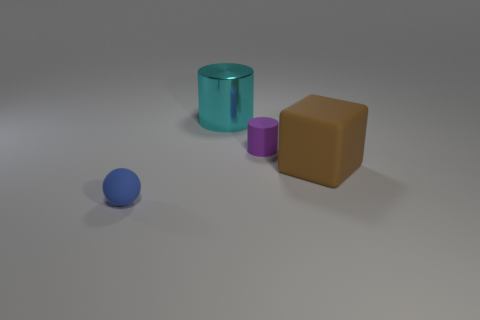Add 4 tiny cyan matte cylinders. How many objects exist? 8 Subtract all blocks. How many objects are left? 3 Add 4 big green objects. How many big green objects exist? 4 Subtract 0 yellow cylinders. How many objects are left? 4 Subtract 1 cubes. How many cubes are left? 0 Subtract all green cylinders. Subtract all green blocks. How many cylinders are left? 2 Subtract all blue balls. How many yellow cylinders are left? 0 Subtract all rubber balls. Subtract all brown objects. How many objects are left? 2 Add 3 balls. How many balls are left? 4 